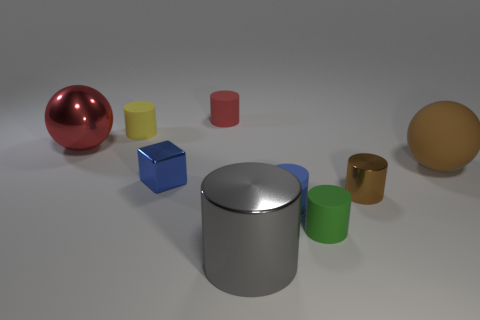Can you explain the lighting in this scene? The scene is illuminated by what appears to be a soft, diffused light source coming from above. This type of lighting reduces harsh shadows and allows for subtle reflections on the shinier objects, such as the gray cylindrical object. It creates a gentle and even ambiance in the image, highlighting the geometry and surface textures without causing strong glare or shadow. 